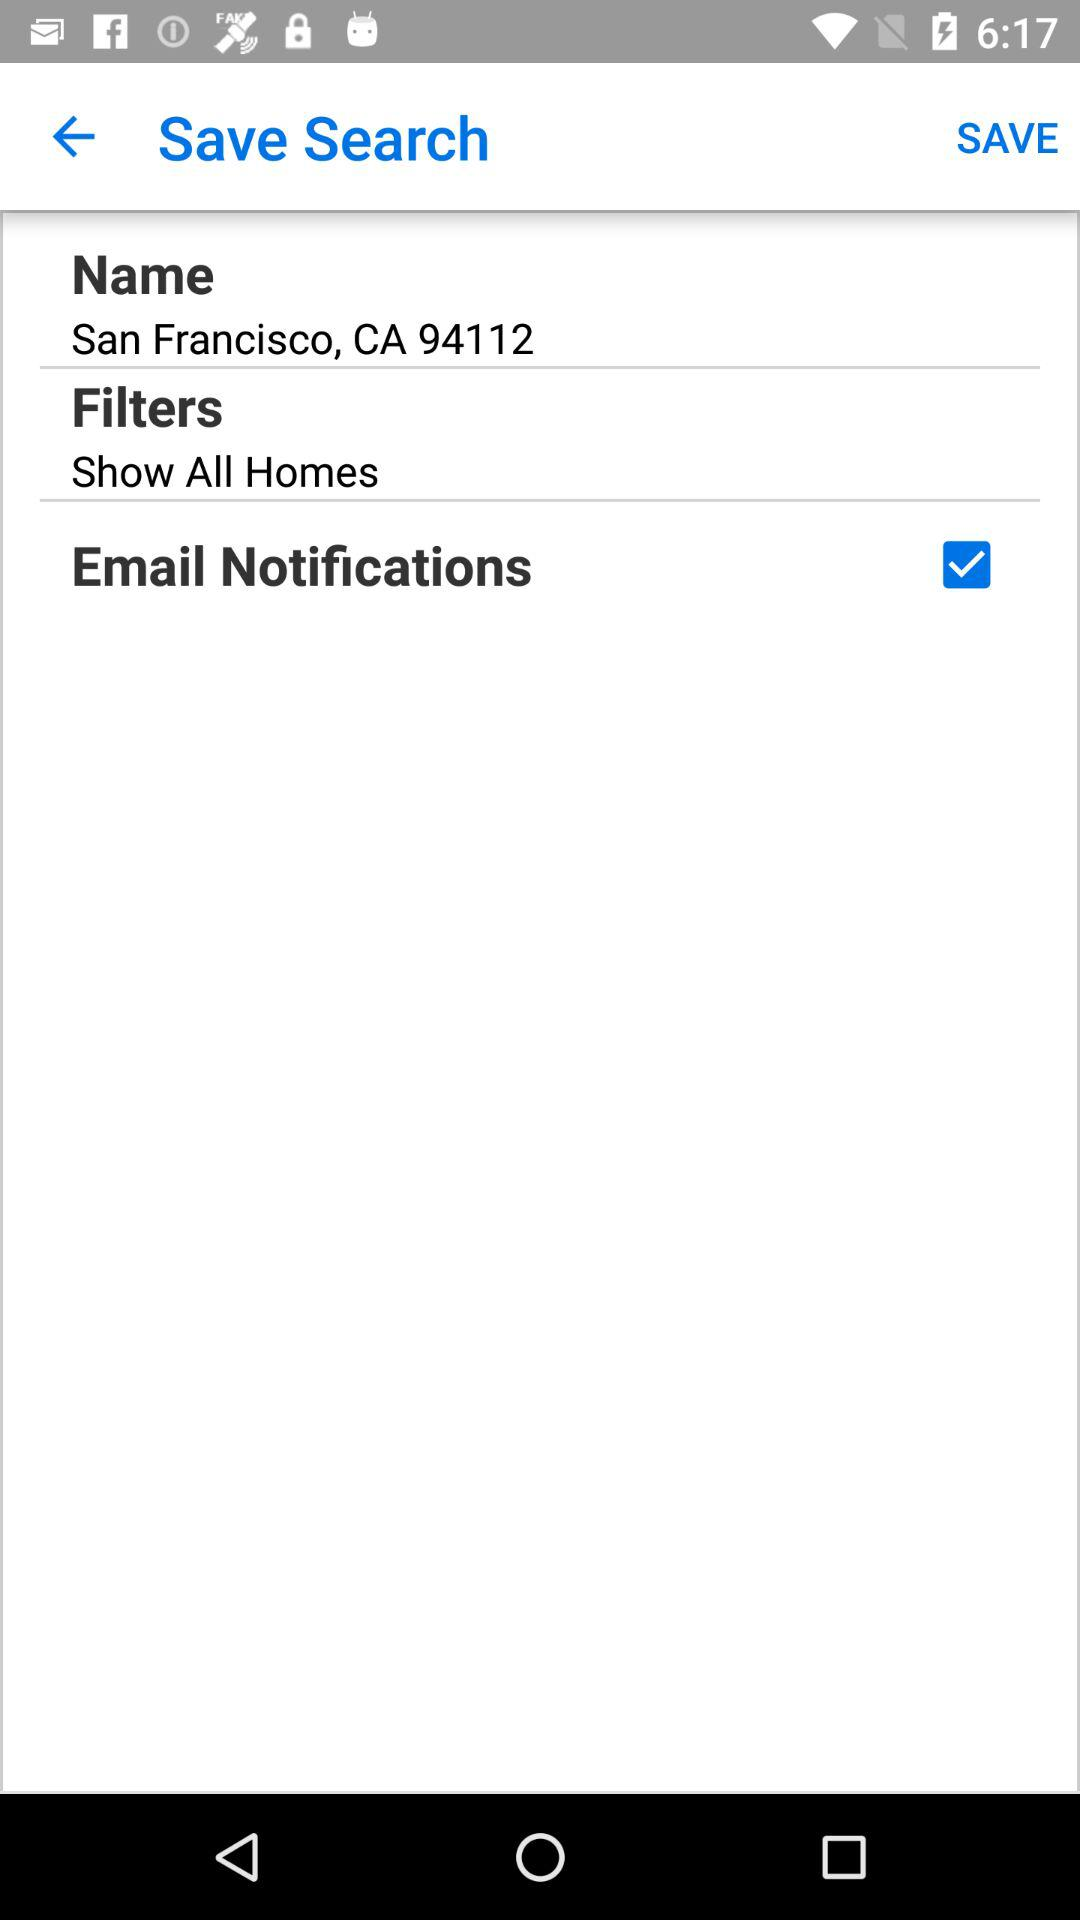What is the status of email notifications? The status is on. 